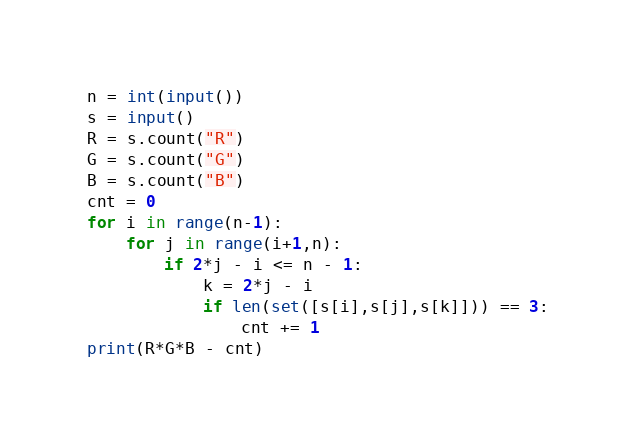Convert code to text. <code><loc_0><loc_0><loc_500><loc_500><_Python_>n = int(input())
s = input()
R = s.count("R")
G = s.count("G")
B = s.count("B")
cnt = 0
for i in range(n-1):
    for j in range(i+1,n):
        if 2*j - i <= n - 1:
            k = 2*j - i
            if len(set([s[i],s[j],s[k]])) == 3:
                cnt += 1
print(R*G*B - cnt)</code> 